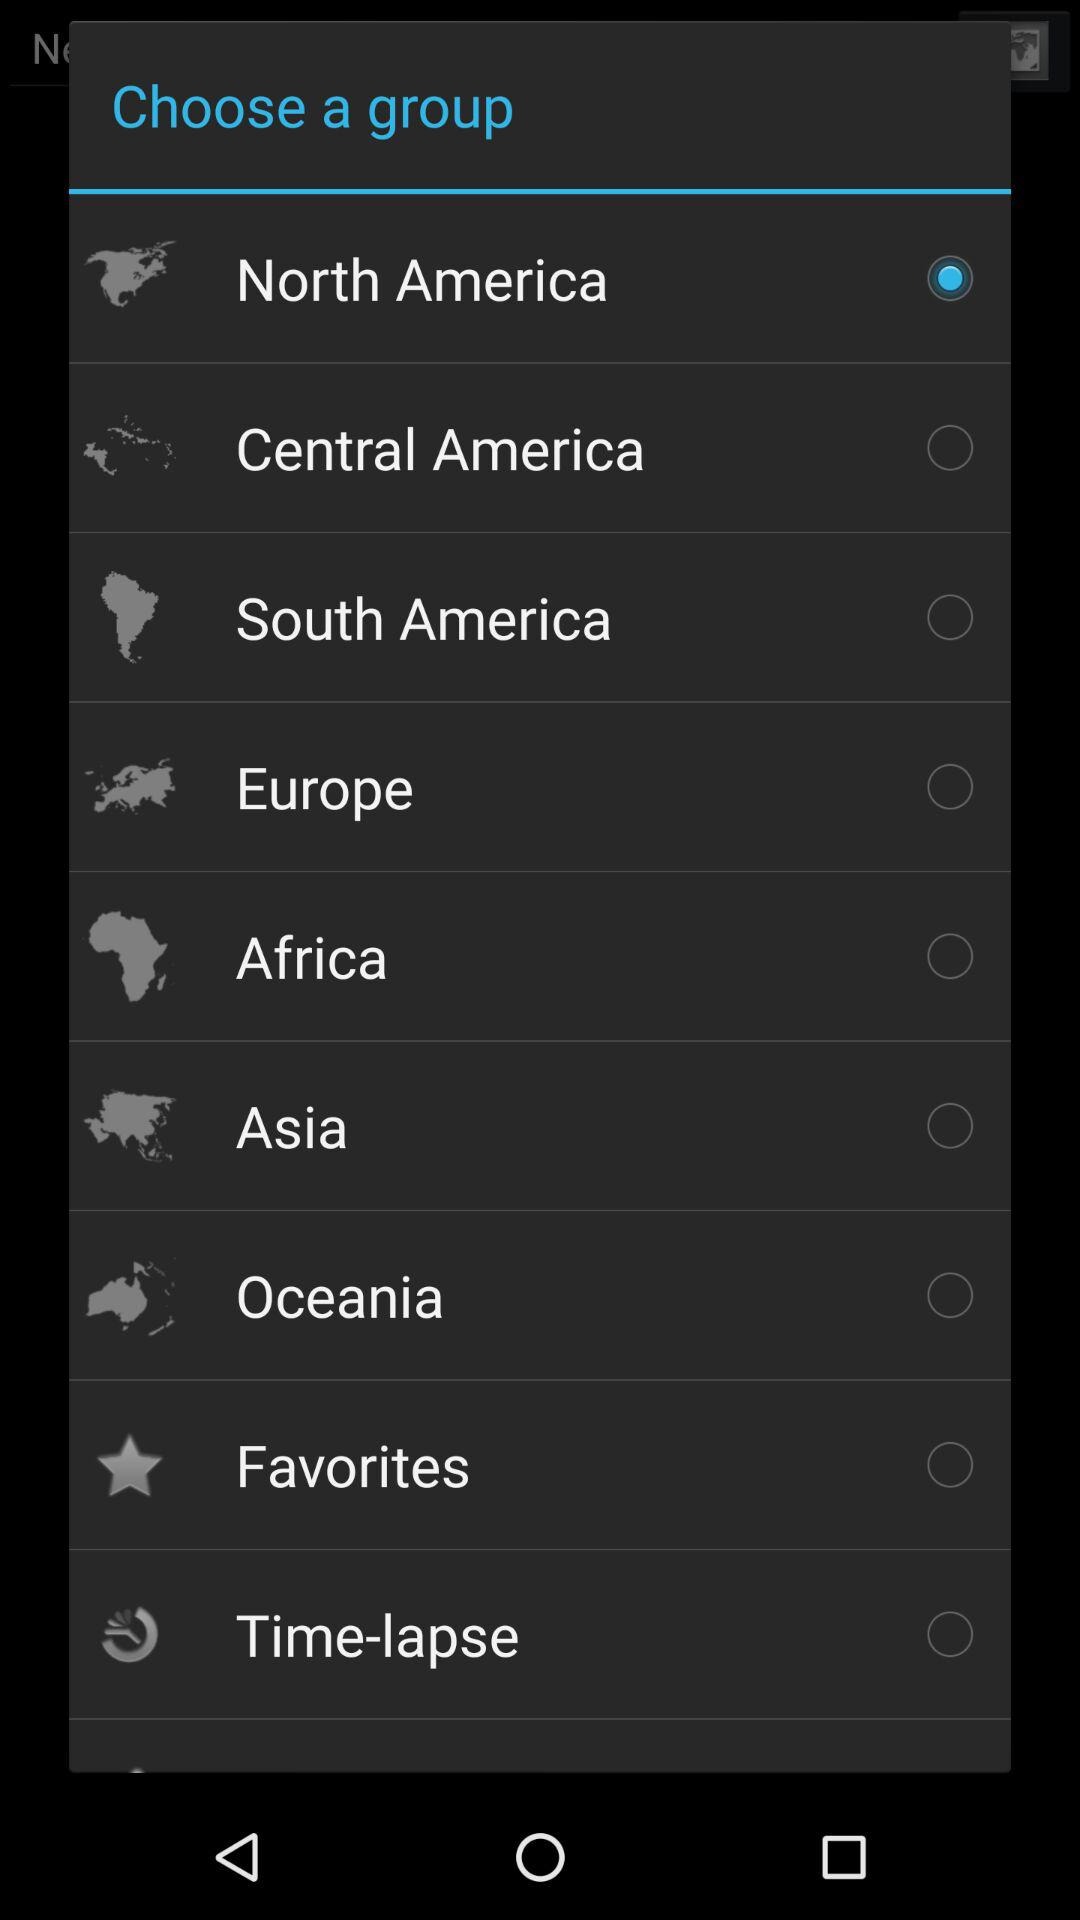What is the selected group? The selected group is "North America". 